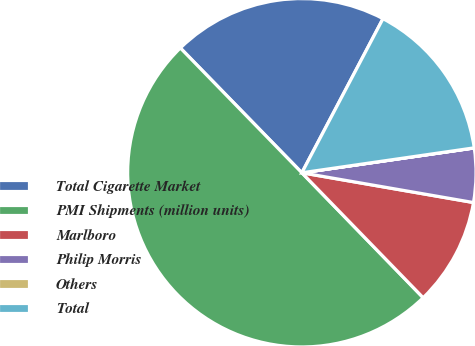Convert chart. <chart><loc_0><loc_0><loc_500><loc_500><pie_chart><fcel>Total Cigarette Market<fcel>PMI Shipments (million units)<fcel>Marlboro<fcel>Philip Morris<fcel>Others<fcel>Total<nl><fcel>20.0%<fcel>49.98%<fcel>10.0%<fcel>5.01%<fcel>0.01%<fcel>15.0%<nl></chart> 